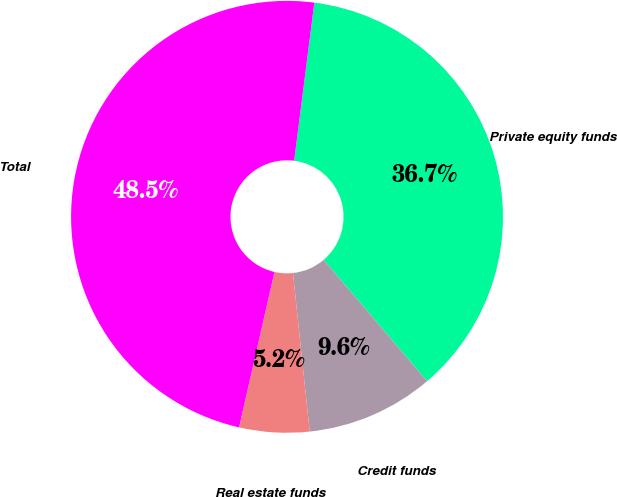<chart> <loc_0><loc_0><loc_500><loc_500><pie_chart><fcel>Private equity funds<fcel>Credit funds<fcel>Real estate funds<fcel>Total<nl><fcel>36.75%<fcel>9.56%<fcel>5.24%<fcel>48.46%<nl></chart> 